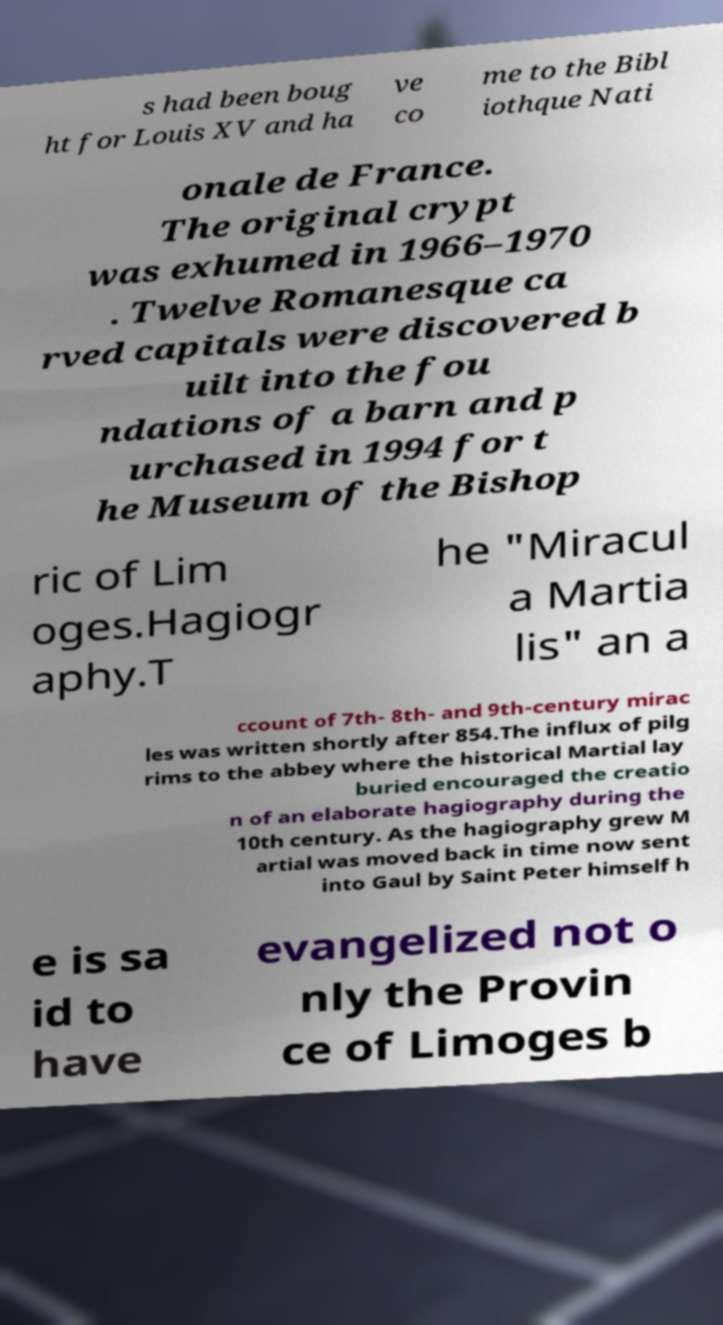For documentation purposes, I need the text within this image transcribed. Could you provide that? s had been boug ht for Louis XV and ha ve co me to the Bibl iothque Nati onale de France. The original crypt was exhumed in 1966–1970 . Twelve Romanesque ca rved capitals were discovered b uilt into the fou ndations of a barn and p urchased in 1994 for t he Museum of the Bishop ric of Lim oges.Hagiogr aphy.T he "Miracul a Martia lis" an a ccount of 7th- 8th- and 9th-century mirac les was written shortly after 854.The influx of pilg rims to the abbey where the historical Martial lay buried encouraged the creatio n of an elaborate hagiography during the 10th century. As the hagiography grew M artial was moved back in time now sent into Gaul by Saint Peter himself h e is sa id to have evangelized not o nly the Provin ce of Limoges b 